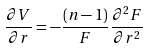Convert formula to latex. <formula><loc_0><loc_0><loc_500><loc_500>\frac { \partial V } { \partial r } = - \frac { ( n - 1 ) } { F } \frac { \partial ^ { 2 } F } { \partial r ^ { 2 } }</formula> 